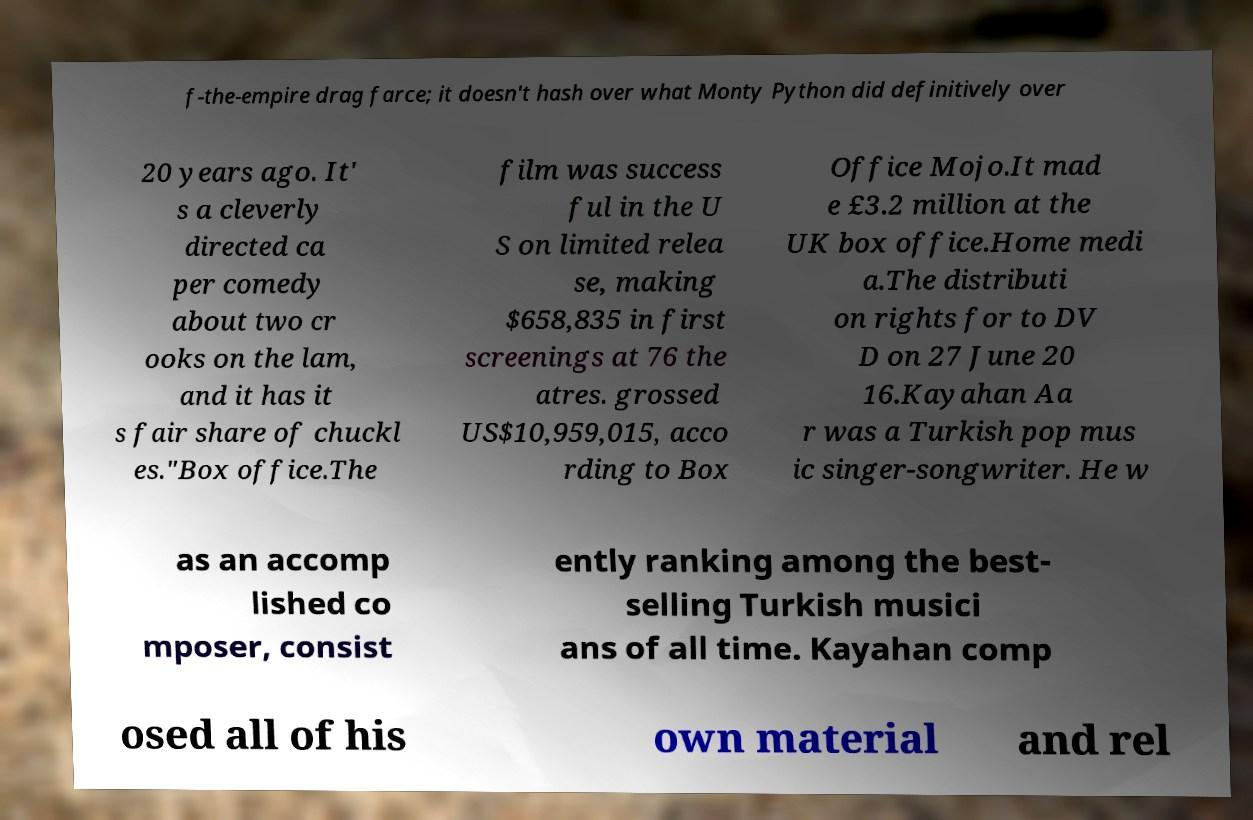Can you read and provide the text displayed in the image?This photo seems to have some interesting text. Can you extract and type it out for me? f-the-empire drag farce; it doesn't hash over what Monty Python did definitively over 20 years ago. It' s a cleverly directed ca per comedy about two cr ooks on the lam, and it has it s fair share of chuckl es."Box office.The film was success ful in the U S on limited relea se, making $658,835 in first screenings at 76 the atres. grossed US$10,959,015, acco rding to Box Office Mojo.It mad e £3.2 million at the UK box office.Home medi a.The distributi on rights for to DV D on 27 June 20 16.Kayahan Aa r was a Turkish pop mus ic singer-songwriter. He w as an accomp lished co mposer, consist ently ranking among the best- selling Turkish musici ans of all time. Kayahan comp osed all of his own material and rel 